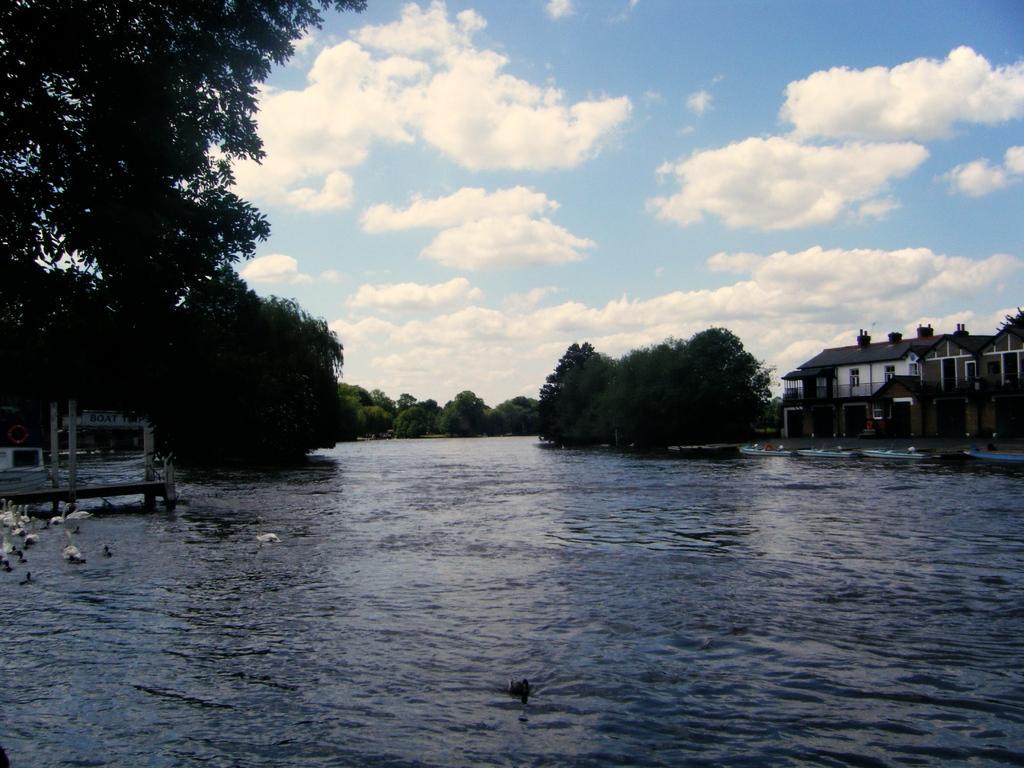In one or two sentences, can you explain what this image depicts? In the image there is water with swans. In the background there are many trees. And there is a building with walls and roofs. At the top of the image there is a sky with clouds. 